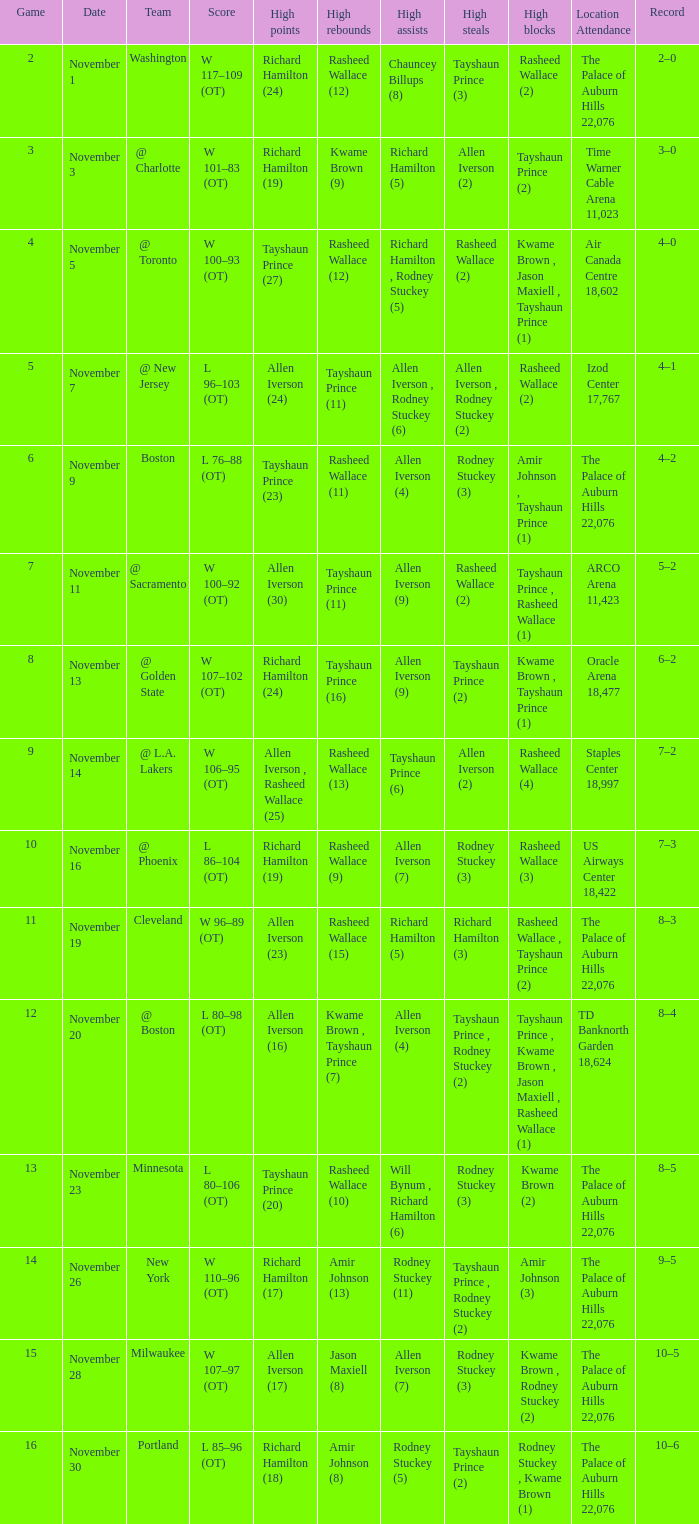What is High Points, when Game is "5"? Allen Iverson (24). 